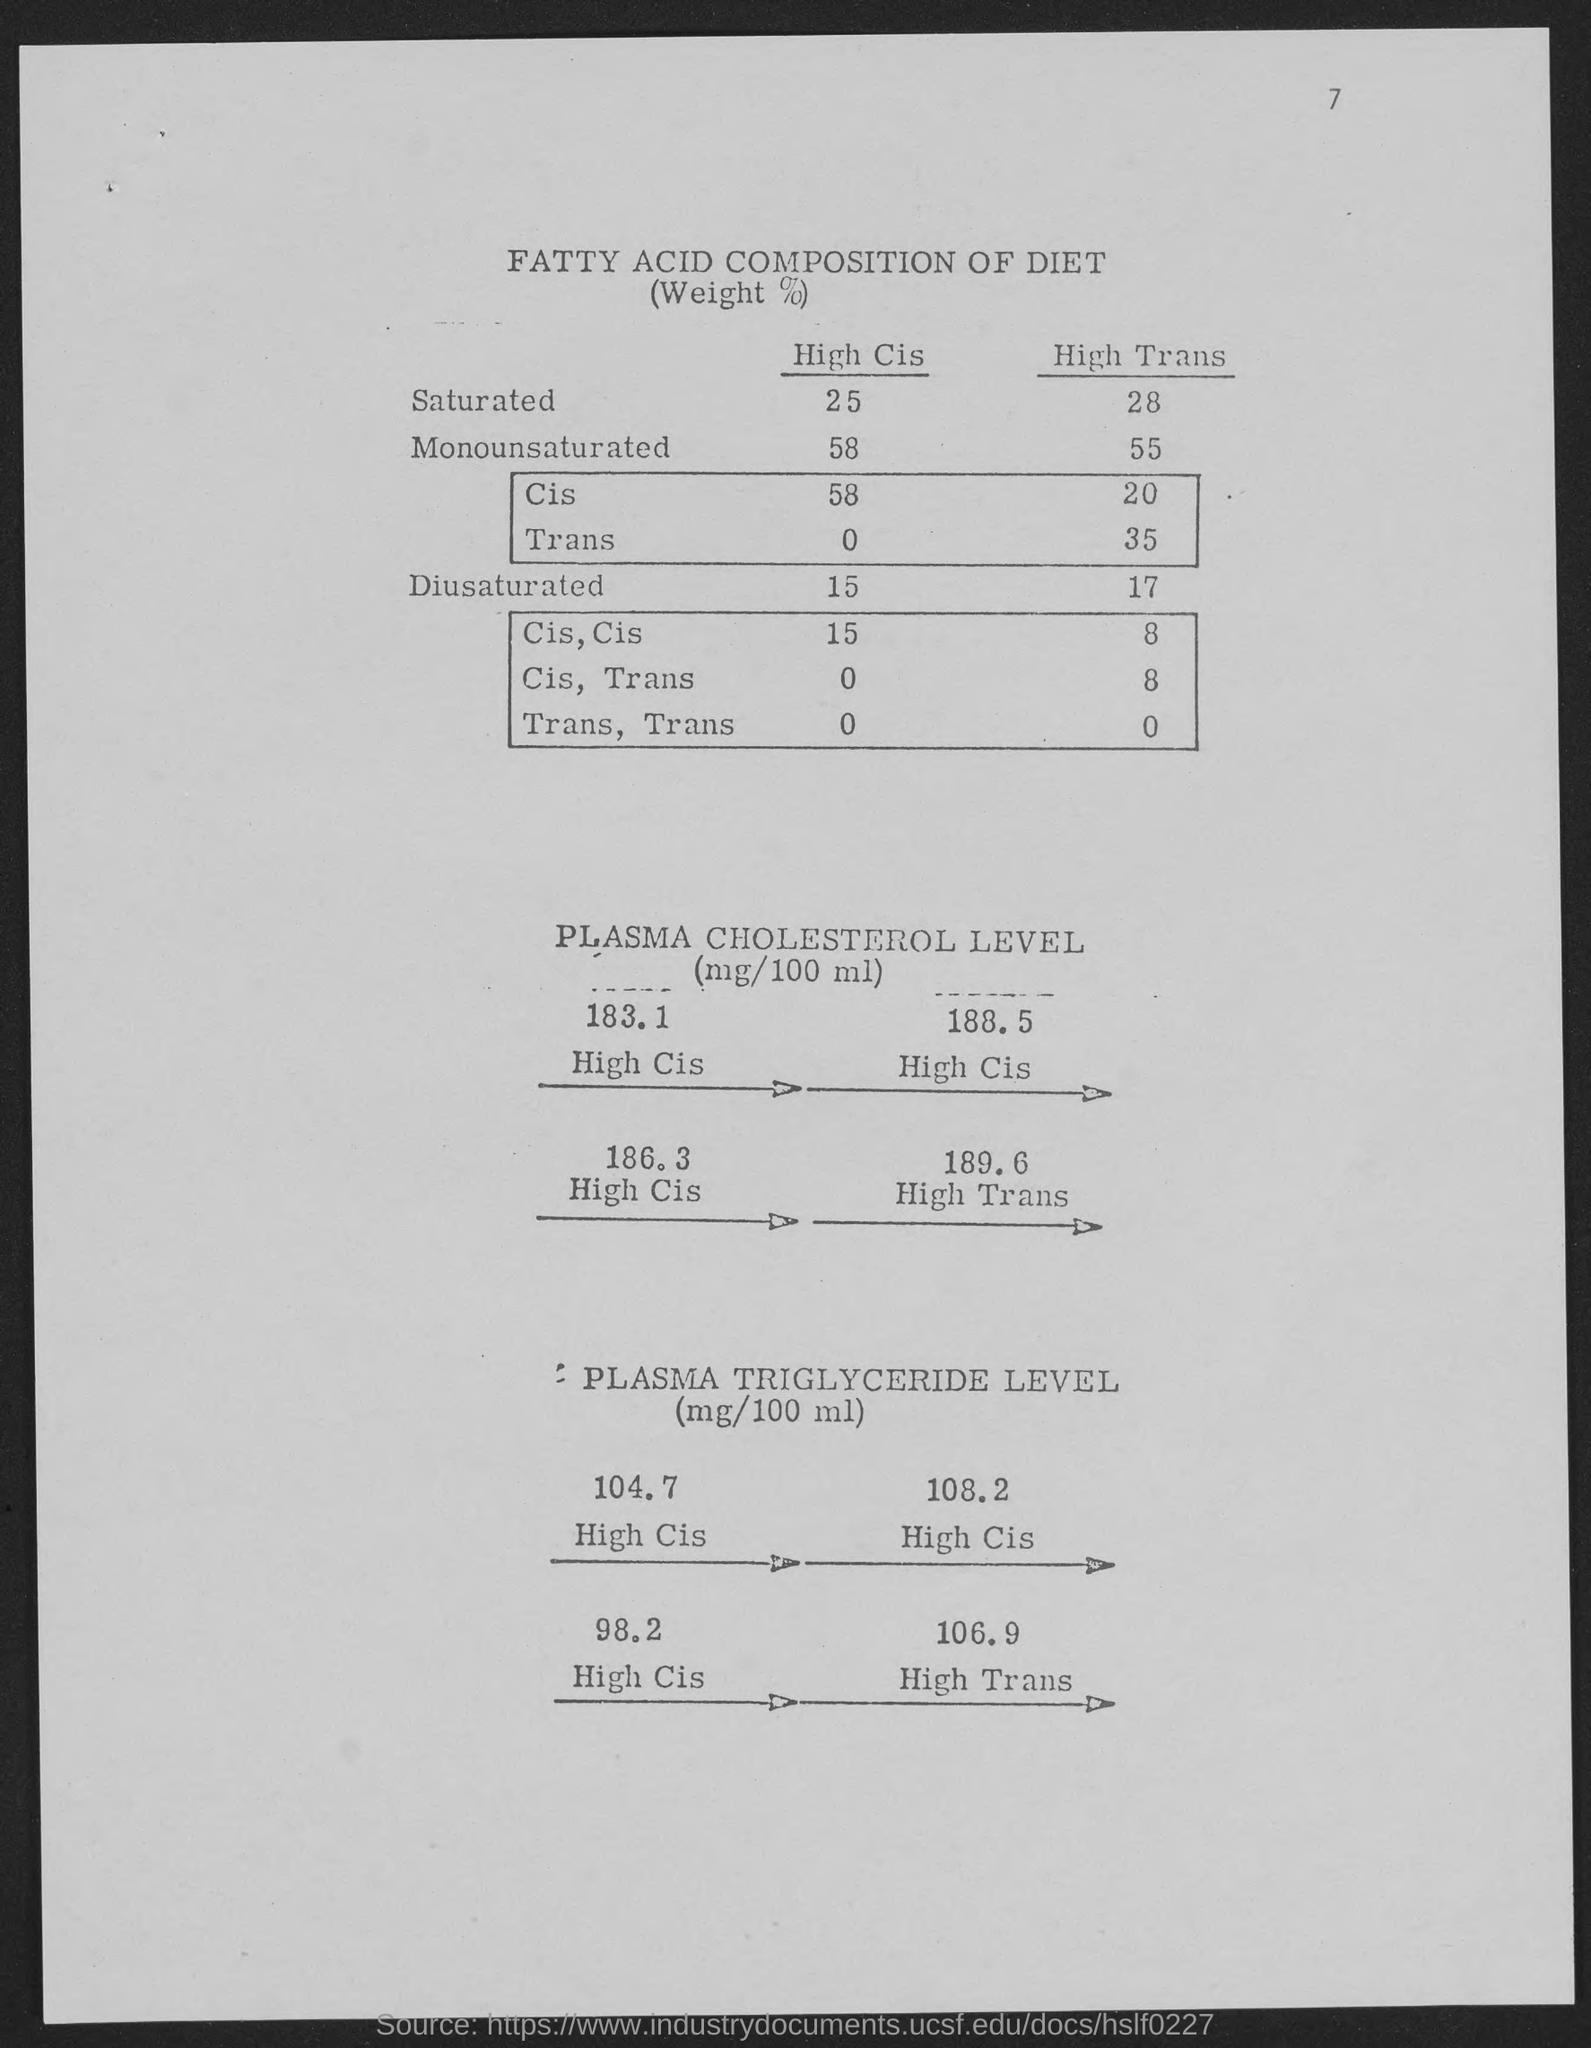What is the number at top-right corner of the page?
Offer a terse response. 7. What is high cis of saturated ?
Ensure brevity in your answer.  25. What is high cis of monounsaturated ?
Your answer should be compact. 58. What is high cis of diusaturated ?
Ensure brevity in your answer.  15. What is high trans of saturated ?
Make the answer very short. 28. What is high trans of monounsaturated ?
Provide a succinct answer. 55. What is hightrans of diusaturated ?
Your response must be concise. 17. 